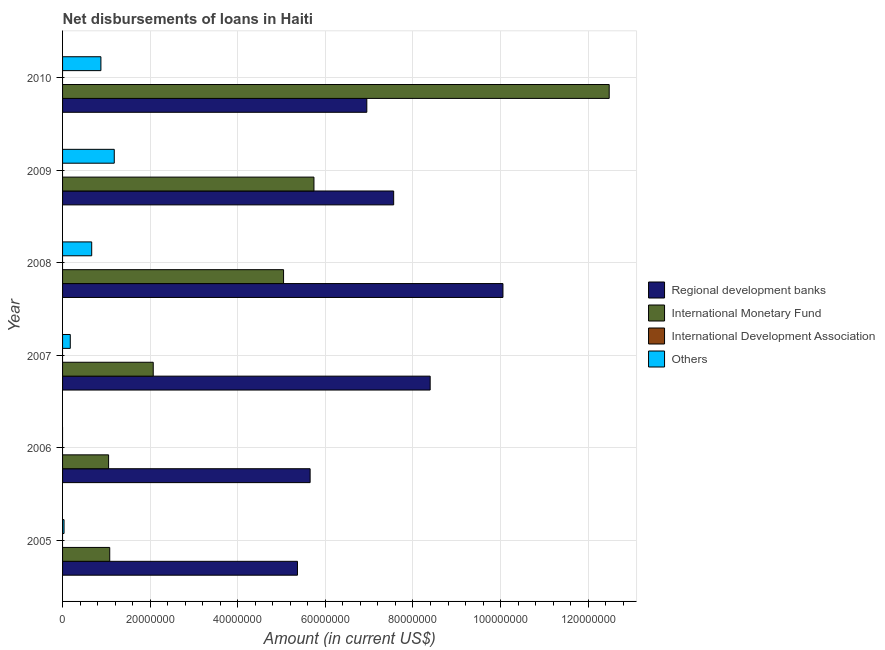How many different coloured bars are there?
Your answer should be very brief. 3. How many bars are there on the 1st tick from the top?
Provide a short and direct response. 3. What is the amount of loan disimbursed by other organisations in 2010?
Keep it short and to the point. 8.75e+06. Across all years, what is the maximum amount of loan disimbursed by regional development banks?
Offer a very short reply. 1.01e+08. Across all years, what is the minimum amount of loan disimbursed by international monetary fund?
Make the answer very short. 1.05e+07. In which year was the amount of loan disimbursed by international monetary fund maximum?
Make the answer very short. 2010. What is the total amount of loan disimbursed by other organisations in the graph?
Ensure brevity in your answer.  2.93e+07. What is the difference between the amount of loan disimbursed by regional development banks in 2009 and that in 2010?
Ensure brevity in your answer.  6.13e+06. What is the difference between the amount of loan disimbursed by regional development banks in 2009 and the amount of loan disimbursed by international development association in 2006?
Your answer should be compact. 7.56e+07. What is the average amount of loan disimbursed by other organisations per year?
Offer a terse response. 4.88e+06. In the year 2005, what is the difference between the amount of loan disimbursed by other organisations and amount of loan disimbursed by international monetary fund?
Keep it short and to the point. -1.04e+07. In how many years, is the amount of loan disimbursed by other organisations greater than 24000000 US$?
Provide a short and direct response. 0. What is the ratio of the amount of loan disimbursed by regional development banks in 2005 to that in 2006?
Ensure brevity in your answer.  0.95. Is the amount of loan disimbursed by international monetary fund in 2005 less than that in 2009?
Your answer should be compact. Yes. What is the difference between the highest and the second highest amount of loan disimbursed by international monetary fund?
Ensure brevity in your answer.  6.74e+07. What is the difference between the highest and the lowest amount of loan disimbursed by regional development banks?
Provide a short and direct response. 4.69e+07. In how many years, is the amount of loan disimbursed by international development association greater than the average amount of loan disimbursed by international development association taken over all years?
Your answer should be compact. 0. Is it the case that in every year, the sum of the amount of loan disimbursed by regional development banks and amount of loan disimbursed by international monetary fund is greater than the amount of loan disimbursed by international development association?
Offer a terse response. Yes. Are the values on the major ticks of X-axis written in scientific E-notation?
Ensure brevity in your answer.  No. Does the graph contain grids?
Offer a terse response. Yes. How many legend labels are there?
Ensure brevity in your answer.  4. What is the title of the graph?
Your answer should be very brief. Net disbursements of loans in Haiti. Does "Others" appear as one of the legend labels in the graph?
Make the answer very short. Yes. What is the label or title of the X-axis?
Provide a succinct answer. Amount (in current US$). What is the label or title of the Y-axis?
Keep it short and to the point. Year. What is the Amount (in current US$) in Regional development banks in 2005?
Your response must be concise. 5.36e+07. What is the Amount (in current US$) in International Monetary Fund in 2005?
Give a very brief answer. 1.08e+07. What is the Amount (in current US$) of Others in 2005?
Keep it short and to the point. 3.37e+05. What is the Amount (in current US$) in Regional development banks in 2006?
Your answer should be compact. 5.65e+07. What is the Amount (in current US$) of International Monetary Fund in 2006?
Offer a terse response. 1.05e+07. What is the Amount (in current US$) of International Development Association in 2006?
Offer a very short reply. 0. What is the Amount (in current US$) of Others in 2006?
Keep it short and to the point. 0. What is the Amount (in current US$) in Regional development banks in 2007?
Provide a short and direct response. 8.39e+07. What is the Amount (in current US$) of International Monetary Fund in 2007?
Offer a very short reply. 2.07e+07. What is the Amount (in current US$) of Others in 2007?
Your response must be concise. 1.76e+06. What is the Amount (in current US$) of Regional development banks in 2008?
Your answer should be very brief. 1.01e+08. What is the Amount (in current US$) of International Monetary Fund in 2008?
Ensure brevity in your answer.  5.05e+07. What is the Amount (in current US$) of International Development Association in 2008?
Your response must be concise. 0. What is the Amount (in current US$) of Others in 2008?
Give a very brief answer. 6.65e+06. What is the Amount (in current US$) in Regional development banks in 2009?
Your answer should be compact. 7.56e+07. What is the Amount (in current US$) of International Monetary Fund in 2009?
Offer a very short reply. 5.74e+07. What is the Amount (in current US$) of International Development Association in 2009?
Offer a terse response. 0. What is the Amount (in current US$) in Others in 2009?
Make the answer very short. 1.18e+07. What is the Amount (in current US$) in Regional development banks in 2010?
Make the answer very short. 6.95e+07. What is the Amount (in current US$) of International Monetary Fund in 2010?
Offer a very short reply. 1.25e+08. What is the Amount (in current US$) of Others in 2010?
Your answer should be compact. 8.75e+06. Across all years, what is the maximum Amount (in current US$) of Regional development banks?
Provide a short and direct response. 1.01e+08. Across all years, what is the maximum Amount (in current US$) in International Monetary Fund?
Your answer should be very brief. 1.25e+08. Across all years, what is the maximum Amount (in current US$) of Others?
Provide a succinct answer. 1.18e+07. Across all years, what is the minimum Amount (in current US$) of Regional development banks?
Offer a very short reply. 5.36e+07. Across all years, what is the minimum Amount (in current US$) in International Monetary Fund?
Your answer should be compact. 1.05e+07. Across all years, what is the minimum Amount (in current US$) of Others?
Ensure brevity in your answer.  0. What is the total Amount (in current US$) of Regional development banks in the graph?
Ensure brevity in your answer.  4.40e+08. What is the total Amount (in current US$) of International Monetary Fund in the graph?
Your response must be concise. 2.75e+08. What is the total Amount (in current US$) in International Development Association in the graph?
Ensure brevity in your answer.  0. What is the total Amount (in current US$) of Others in the graph?
Ensure brevity in your answer.  2.93e+07. What is the difference between the Amount (in current US$) in Regional development banks in 2005 and that in 2006?
Your answer should be very brief. -2.89e+06. What is the difference between the Amount (in current US$) of International Monetary Fund in 2005 and that in 2006?
Give a very brief answer. 2.58e+05. What is the difference between the Amount (in current US$) in Regional development banks in 2005 and that in 2007?
Offer a very short reply. -3.03e+07. What is the difference between the Amount (in current US$) in International Monetary Fund in 2005 and that in 2007?
Provide a short and direct response. -9.93e+06. What is the difference between the Amount (in current US$) of Others in 2005 and that in 2007?
Your response must be concise. -1.42e+06. What is the difference between the Amount (in current US$) of Regional development banks in 2005 and that in 2008?
Your answer should be very brief. -4.69e+07. What is the difference between the Amount (in current US$) of International Monetary Fund in 2005 and that in 2008?
Your response must be concise. -3.97e+07. What is the difference between the Amount (in current US$) of Others in 2005 and that in 2008?
Offer a terse response. -6.32e+06. What is the difference between the Amount (in current US$) in Regional development banks in 2005 and that in 2009?
Your answer should be very brief. -2.20e+07. What is the difference between the Amount (in current US$) of International Monetary Fund in 2005 and that in 2009?
Offer a terse response. -4.66e+07. What is the difference between the Amount (in current US$) of Others in 2005 and that in 2009?
Your answer should be compact. -1.15e+07. What is the difference between the Amount (in current US$) in Regional development banks in 2005 and that in 2010?
Provide a succinct answer. -1.58e+07. What is the difference between the Amount (in current US$) of International Monetary Fund in 2005 and that in 2010?
Provide a succinct answer. -1.14e+08. What is the difference between the Amount (in current US$) of Others in 2005 and that in 2010?
Keep it short and to the point. -8.42e+06. What is the difference between the Amount (in current US$) of Regional development banks in 2006 and that in 2007?
Your answer should be very brief. -2.74e+07. What is the difference between the Amount (in current US$) of International Monetary Fund in 2006 and that in 2007?
Make the answer very short. -1.02e+07. What is the difference between the Amount (in current US$) of Regional development banks in 2006 and that in 2008?
Offer a terse response. -4.40e+07. What is the difference between the Amount (in current US$) in International Monetary Fund in 2006 and that in 2008?
Offer a very short reply. -3.99e+07. What is the difference between the Amount (in current US$) of Regional development banks in 2006 and that in 2009?
Provide a short and direct response. -1.91e+07. What is the difference between the Amount (in current US$) of International Monetary Fund in 2006 and that in 2009?
Give a very brief answer. -4.69e+07. What is the difference between the Amount (in current US$) of Regional development banks in 2006 and that in 2010?
Offer a very short reply. -1.29e+07. What is the difference between the Amount (in current US$) of International Monetary Fund in 2006 and that in 2010?
Provide a succinct answer. -1.14e+08. What is the difference between the Amount (in current US$) of Regional development banks in 2007 and that in 2008?
Your answer should be compact. -1.66e+07. What is the difference between the Amount (in current US$) in International Monetary Fund in 2007 and that in 2008?
Provide a short and direct response. -2.98e+07. What is the difference between the Amount (in current US$) in Others in 2007 and that in 2008?
Give a very brief answer. -4.89e+06. What is the difference between the Amount (in current US$) in Regional development banks in 2007 and that in 2009?
Give a very brief answer. 8.33e+06. What is the difference between the Amount (in current US$) in International Monetary Fund in 2007 and that in 2009?
Provide a short and direct response. -3.67e+07. What is the difference between the Amount (in current US$) in Others in 2007 and that in 2009?
Your answer should be very brief. -1.00e+07. What is the difference between the Amount (in current US$) in Regional development banks in 2007 and that in 2010?
Keep it short and to the point. 1.45e+07. What is the difference between the Amount (in current US$) of International Monetary Fund in 2007 and that in 2010?
Your answer should be very brief. -1.04e+08. What is the difference between the Amount (in current US$) in Others in 2007 and that in 2010?
Make the answer very short. -6.99e+06. What is the difference between the Amount (in current US$) in Regional development banks in 2008 and that in 2009?
Give a very brief answer. 2.50e+07. What is the difference between the Amount (in current US$) of International Monetary Fund in 2008 and that in 2009?
Your answer should be very brief. -6.94e+06. What is the difference between the Amount (in current US$) in Others in 2008 and that in 2009?
Give a very brief answer. -5.15e+06. What is the difference between the Amount (in current US$) in Regional development banks in 2008 and that in 2010?
Your answer should be compact. 3.11e+07. What is the difference between the Amount (in current US$) in International Monetary Fund in 2008 and that in 2010?
Your answer should be very brief. -7.43e+07. What is the difference between the Amount (in current US$) in Others in 2008 and that in 2010?
Make the answer very short. -2.10e+06. What is the difference between the Amount (in current US$) of Regional development banks in 2009 and that in 2010?
Keep it short and to the point. 6.13e+06. What is the difference between the Amount (in current US$) of International Monetary Fund in 2009 and that in 2010?
Provide a short and direct response. -6.74e+07. What is the difference between the Amount (in current US$) of Others in 2009 and that in 2010?
Ensure brevity in your answer.  3.05e+06. What is the difference between the Amount (in current US$) in Regional development banks in 2005 and the Amount (in current US$) in International Monetary Fund in 2006?
Provide a short and direct response. 4.31e+07. What is the difference between the Amount (in current US$) of Regional development banks in 2005 and the Amount (in current US$) of International Monetary Fund in 2007?
Your response must be concise. 3.29e+07. What is the difference between the Amount (in current US$) of Regional development banks in 2005 and the Amount (in current US$) of Others in 2007?
Offer a terse response. 5.19e+07. What is the difference between the Amount (in current US$) in International Monetary Fund in 2005 and the Amount (in current US$) in Others in 2007?
Keep it short and to the point. 9.00e+06. What is the difference between the Amount (in current US$) of Regional development banks in 2005 and the Amount (in current US$) of International Monetary Fund in 2008?
Provide a short and direct response. 3.18e+06. What is the difference between the Amount (in current US$) in Regional development banks in 2005 and the Amount (in current US$) in Others in 2008?
Your answer should be compact. 4.70e+07. What is the difference between the Amount (in current US$) in International Monetary Fund in 2005 and the Amount (in current US$) in Others in 2008?
Make the answer very short. 4.12e+06. What is the difference between the Amount (in current US$) of Regional development banks in 2005 and the Amount (in current US$) of International Monetary Fund in 2009?
Your response must be concise. -3.76e+06. What is the difference between the Amount (in current US$) in Regional development banks in 2005 and the Amount (in current US$) in Others in 2009?
Ensure brevity in your answer.  4.18e+07. What is the difference between the Amount (in current US$) of International Monetary Fund in 2005 and the Amount (in current US$) of Others in 2009?
Provide a succinct answer. -1.04e+06. What is the difference between the Amount (in current US$) in Regional development banks in 2005 and the Amount (in current US$) in International Monetary Fund in 2010?
Your answer should be compact. -7.12e+07. What is the difference between the Amount (in current US$) in Regional development banks in 2005 and the Amount (in current US$) in Others in 2010?
Provide a succinct answer. 4.49e+07. What is the difference between the Amount (in current US$) in International Monetary Fund in 2005 and the Amount (in current US$) in Others in 2010?
Ensure brevity in your answer.  2.01e+06. What is the difference between the Amount (in current US$) of Regional development banks in 2006 and the Amount (in current US$) of International Monetary Fund in 2007?
Make the answer very short. 3.58e+07. What is the difference between the Amount (in current US$) of Regional development banks in 2006 and the Amount (in current US$) of Others in 2007?
Provide a succinct answer. 5.48e+07. What is the difference between the Amount (in current US$) of International Monetary Fund in 2006 and the Amount (in current US$) of Others in 2007?
Provide a short and direct response. 8.75e+06. What is the difference between the Amount (in current US$) in Regional development banks in 2006 and the Amount (in current US$) in International Monetary Fund in 2008?
Provide a short and direct response. 6.06e+06. What is the difference between the Amount (in current US$) of Regional development banks in 2006 and the Amount (in current US$) of Others in 2008?
Keep it short and to the point. 4.99e+07. What is the difference between the Amount (in current US$) in International Monetary Fund in 2006 and the Amount (in current US$) in Others in 2008?
Ensure brevity in your answer.  3.86e+06. What is the difference between the Amount (in current US$) in Regional development banks in 2006 and the Amount (in current US$) in International Monetary Fund in 2009?
Your answer should be compact. -8.72e+05. What is the difference between the Amount (in current US$) in Regional development banks in 2006 and the Amount (in current US$) in Others in 2009?
Give a very brief answer. 4.47e+07. What is the difference between the Amount (in current US$) in International Monetary Fund in 2006 and the Amount (in current US$) in Others in 2009?
Make the answer very short. -1.29e+06. What is the difference between the Amount (in current US$) of Regional development banks in 2006 and the Amount (in current US$) of International Monetary Fund in 2010?
Make the answer very short. -6.83e+07. What is the difference between the Amount (in current US$) of Regional development banks in 2006 and the Amount (in current US$) of Others in 2010?
Offer a very short reply. 4.78e+07. What is the difference between the Amount (in current US$) of International Monetary Fund in 2006 and the Amount (in current US$) of Others in 2010?
Give a very brief answer. 1.76e+06. What is the difference between the Amount (in current US$) in Regional development banks in 2007 and the Amount (in current US$) in International Monetary Fund in 2008?
Offer a very short reply. 3.35e+07. What is the difference between the Amount (in current US$) in Regional development banks in 2007 and the Amount (in current US$) in Others in 2008?
Your answer should be very brief. 7.73e+07. What is the difference between the Amount (in current US$) of International Monetary Fund in 2007 and the Amount (in current US$) of Others in 2008?
Make the answer very short. 1.40e+07. What is the difference between the Amount (in current US$) in Regional development banks in 2007 and the Amount (in current US$) in International Monetary Fund in 2009?
Your answer should be very brief. 2.65e+07. What is the difference between the Amount (in current US$) of Regional development banks in 2007 and the Amount (in current US$) of Others in 2009?
Provide a short and direct response. 7.21e+07. What is the difference between the Amount (in current US$) of International Monetary Fund in 2007 and the Amount (in current US$) of Others in 2009?
Provide a succinct answer. 8.90e+06. What is the difference between the Amount (in current US$) of Regional development banks in 2007 and the Amount (in current US$) of International Monetary Fund in 2010?
Offer a very short reply. -4.09e+07. What is the difference between the Amount (in current US$) in Regional development banks in 2007 and the Amount (in current US$) in Others in 2010?
Offer a very short reply. 7.52e+07. What is the difference between the Amount (in current US$) in International Monetary Fund in 2007 and the Amount (in current US$) in Others in 2010?
Make the answer very short. 1.19e+07. What is the difference between the Amount (in current US$) in Regional development banks in 2008 and the Amount (in current US$) in International Monetary Fund in 2009?
Your answer should be very brief. 4.32e+07. What is the difference between the Amount (in current US$) of Regional development banks in 2008 and the Amount (in current US$) of Others in 2009?
Provide a short and direct response. 8.87e+07. What is the difference between the Amount (in current US$) of International Monetary Fund in 2008 and the Amount (in current US$) of Others in 2009?
Make the answer very short. 3.86e+07. What is the difference between the Amount (in current US$) of Regional development banks in 2008 and the Amount (in current US$) of International Monetary Fund in 2010?
Make the answer very short. -2.43e+07. What is the difference between the Amount (in current US$) of Regional development banks in 2008 and the Amount (in current US$) of Others in 2010?
Ensure brevity in your answer.  9.18e+07. What is the difference between the Amount (in current US$) in International Monetary Fund in 2008 and the Amount (in current US$) in Others in 2010?
Offer a very short reply. 4.17e+07. What is the difference between the Amount (in current US$) in Regional development banks in 2009 and the Amount (in current US$) in International Monetary Fund in 2010?
Your answer should be compact. -4.92e+07. What is the difference between the Amount (in current US$) in Regional development banks in 2009 and the Amount (in current US$) in Others in 2010?
Keep it short and to the point. 6.68e+07. What is the difference between the Amount (in current US$) in International Monetary Fund in 2009 and the Amount (in current US$) in Others in 2010?
Keep it short and to the point. 4.86e+07. What is the average Amount (in current US$) of Regional development banks per year?
Provide a short and direct response. 7.33e+07. What is the average Amount (in current US$) of International Monetary Fund per year?
Offer a very short reply. 4.58e+07. What is the average Amount (in current US$) in Others per year?
Ensure brevity in your answer.  4.88e+06. In the year 2005, what is the difference between the Amount (in current US$) in Regional development banks and Amount (in current US$) in International Monetary Fund?
Keep it short and to the point. 4.29e+07. In the year 2005, what is the difference between the Amount (in current US$) of Regional development banks and Amount (in current US$) of Others?
Provide a succinct answer. 5.33e+07. In the year 2005, what is the difference between the Amount (in current US$) in International Monetary Fund and Amount (in current US$) in Others?
Your answer should be very brief. 1.04e+07. In the year 2006, what is the difference between the Amount (in current US$) in Regional development banks and Amount (in current US$) in International Monetary Fund?
Make the answer very short. 4.60e+07. In the year 2007, what is the difference between the Amount (in current US$) in Regional development banks and Amount (in current US$) in International Monetary Fund?
Ensure brevity in your answer.  6.32e+07. In the year 2007, what is the difference between the Amount (in current US$) of Regional development banks and Amount (in current US$) of Others?
Your answer should be very brief. 8.22e+07. In the year 2007, what is the difference between the Amount (in current US$) of International Monetary Fund and Amount (in current US$) of Others?
Keep it short and to the point. 1.89e+07. In the year 2008, what is the difference between the Amount (in current US$) of Regional development banks and Amount (in current US$) of International Monetary Fund?
Offer a very short reply. 5.01e+07. In the year 2008, what is the difference between the Amount (in current US$) in Regional development banks and Amount (in current US$) in Others?
Your answer should be very brief. 9.39e+07. In the year 2008, what is the difference between the Amount (in current US$) of International Monetary Fund and Amount (in current US$) of Others?
Provide a short and direct response. 4.38e+07. In the year 2009, what is the difference between the Amount (in current US$) of Regional development banks and Amount (in current US$) of International Monetary Fund?
Keep it short and to the point. 1.82e+07. In the year 2009, what is the difference between the Amount (in current US$) in Regional development banks and Amount (in current US$) in Others?
Your answer should be compact. 6.38e+07. In the year 2009, what is the difference between the Amount (in current US$) of International Monetary Fund and Amount (in current US$) of Others?
Provide a succinct answer. 4.56e+07. In the year 2010, what is the difference between the Amount (in current US$) in Regional development banks and Amount (in current US$) in International Monetary Fund?
Ensure brevity in your answer.  -5.53e+07. In the year 2010, what is the difference between the Amount (in current US$) in Regional development banks and Amount (in current US$) in Others?
Give a very brief answer. 6.07e+07. In the year 2010, what is the difference between the Amount (in current US$) in International Monetary Fund and Amount (in current US$) in Others?
Provide a short and direct response. 1.16e+08. What is the ratio of the Amount (in current US$) in Regional development banks in 2005 to that in 2006?
Make the answer very short. 0.95. What is the ratio of the Amount (in current US$) of International Monetary Fund in 2005 to that in 2006?
Your response must be concise. 1.02. What is the ratio of the Amount (in current US$) in Regional development banks in 2005 to that in 2007?
Offer a very short reply. 0.64. What is the ratio of the Amount (in current US$) in International Monetary Fund in 2005 to that in 2007?
Offer a terse response. 0.52. What is the ratio of the Amount (in current US$) in Others in 2005 to that in 2007?
Offer a terse response. 0.19. What is the ratio of the Amount (in current US$) in Regional development banks in 2005 to that in 2008?
Your response must be concise. 0.53. What is the ratio of the Amount (in current US$) of International Monetary Fund in 2005 to that in 2008?
Provide a succinct answer. 0.21. What is the ratio of the Amount (in current US$) of Others in 2005 to that in 2008?
Provide a short and direct response. 0.05. What is the ratio of the Amount (in current US$) in Regional development banks in 2005 to that in 2009?
Offer a terse response. 0.71. What is the ratio of the Amount (in current US$) in International Monetary Fund in 2005 to that in 2009?
Ensure brevity in your answer.  0.19. What is the ratio of the Amount (in current US$) of Others in 2005 to that in 2009?
Your answer should be very brief. 0.03. What is the ratio of the Amount (in current US$) in Regional development banks in 2005 to that in 2010?
Offer a terse response. 0.77. What is the ratio of the Amount (in current US$) in International Monetary Fund in 2005 to that in 2010?
Offer a terse response. 0.09. What is the ratio of the Amount (in current US$) of Others in 2005 to that in 2010?
Provide a succinct answer. 0.04. What is the ratio of the Amount (in current US$) in Regional development banks in 2006 to that in 2007?
Give a very brief answer. 0.67. What is the ratio of the Amount (in current US$) in International Monetary Fund in 2006 to that in 2007?
Provide a short and direct response. 0.51. What is the ratio of the Amount (in current US$) in Regional development banks in 2006 to that in 2008?
Keep it short and to the point. 0.56. What is the ratio of the Amount (in current US$) in International Monetary Fund in 2006 to that in 2008?
Make the answer very short. 0.21. What is the ratio of the Amount (in current US$) of Regional development banks in 2006 to that in 2009?
Your answer should be very brief. 0.75. What is the ratio of the Amount (in current US$) of International Monetary Fund in 2006 to that in 2009?
Provide a succinct answer. 0.18. What is the ratio of the Amount (in current US$) of Regional development banks in 2006 to that in 2010?
Your answer should be very brief. 0.81. What is the ratio of the Amount (in current US$) in International Monetary Fund in 2006 to that in 2010?
Make the answer very short. 0.08. What is the ratio of the Amount (in current US$) of Regional development banks in 2007 to that in 2008?
Keep it short and to the point. 0.83. What is the ratio of the Amount (in current US$) of International Monetary Fund in 2007 to that in 2008?
Provide a short and direct response. 0.41. What is the ratio of the Amount (in current US$) of Others in 2007 to that in 2008?
Give a very brief answer. 0.26. What is the ratio of the Amount (in current US$) of Regional development banks in 2007 to that in 2009?
Provide a short and direct response. 1.11. What is the ratio of the Amount (in current US$) of International Monetary Fund in 2007 to that in 2009?
Your response must be concise. 0.36. What is the ratio of the Amount (in current US$) of Others in 2007 to that in 2009?
Provide a succinct answer. 0.15. What is the ratio of the Amount (in current US$) in Regional development banks in 2007 to that in 2010?
Provide a succinct answer. 1.21. What is the ratio of the Amount (in current US$) of International Monetary Fund in 2007 to that in 2010?
Ensure brevity in your answer.  0.17. What is the ratio of the Amount (in current US$) in Others in 2007 to that in 2010?
Offer a very short reply. 0.2. What is the ratio of the Amount (in current US$) in Regional development banks in 2008 to that in 2009?
Provide a short and direct response. 1.33. What is the ratio of the Amount (in current US$) in International Monetary Fund in 2008 to that in 2009?
Provide a succinct answer. 0.88. What is the ratio of the Amount (in current US$) of Others in 2008 to that in 2009?
Your answer should be compact. 0.56. What is the ratio of the Amount (in current US$) in Regional development banks in 2008 to that in 2010?
Offer a terse response. 1.45. What is the ratio of the Amount (in current US$) in International Monetary Fund in 2008 to that in 2010?
Make the answer very short. 0.4. What is the ratio of the Amount (in current US$) in Others in 2008 to that in 2010?
Keep it short and to the point. 0.76. What is the ratio of the Amount (in current US$) in Regional development banks in 2009 to that in 2010?
Offer a terse response. 1.09. What is the ratio of the Amount (in current US$) of International Monetary Fund in 2009 to that in 2010?
Your answer should be compact. 0.46. What is the ratio of the Amount (in current US$) in Others in 2009 to that in 2010?
Your response must be concise. 1.35. What is the difference between the highest and the second highest Amount (in current US$) of Regional development banks?
Offer a terse response. 1.66e+07. What is the difference between the highest and the second highest Amount (in current US$) of International Monetary Fund?
Offer a terse response. 6.74e+07. What is the difference between the highest and the second highest Amount (in current US$) of Others?
Provide a short and direct response. 3.05e+06. What is the difference between the highest and the lowest Amount (in current US$) of Regional development banks?
Offer a very short reply. 4.69e+07. What is the difference between the highest and the lowest Amount (in current US$) of International Monetary Fund?
Provide a short and direct response. 1.14e+08. What is the difference between the highest and the lowest Amount (in current US$) in Others?
Keep it short and to the point. 1.18e+07. 